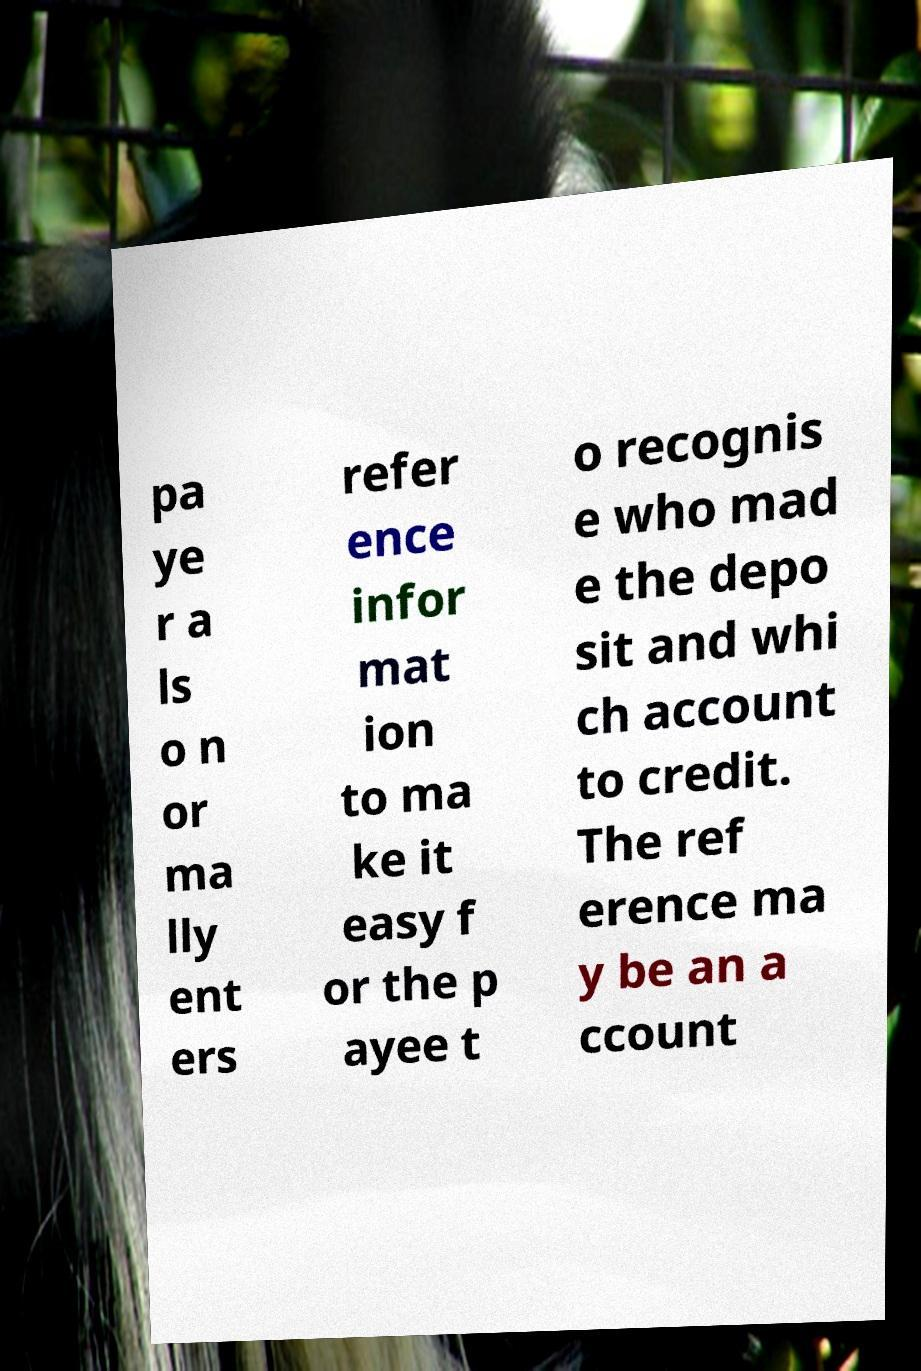Can you read and provide the text displayed in the image?This photo seems to have some interesting text. Can you extract and type it out for me? pa ye r a ls o n or ma lly ent ers refer ence infor mat ion to ma ke it easy f or the p ayee t o recognis e who mad e the depo sit and whi ch account to credit. The ref erence ma y be an a ccount 